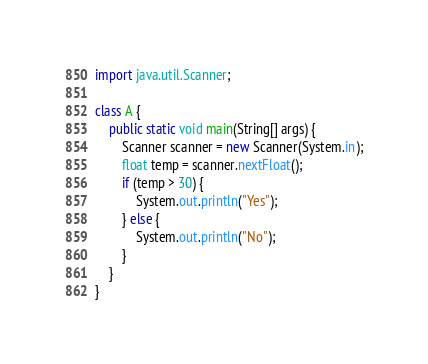Convert code to text. <code><loc_0><loc_0><loc_500><loc_500><_Java_>import java.util.Scanner;

class A {
    public static void main(String[] args) {
        Scanner scanner = new Scanner(System.in);
        float temp = scanner.nextFloat();
        if (temp > 30) {
            System.out.println("Yes");
        } else {
            System.out.println("No");
        }
    }
}
</code> 